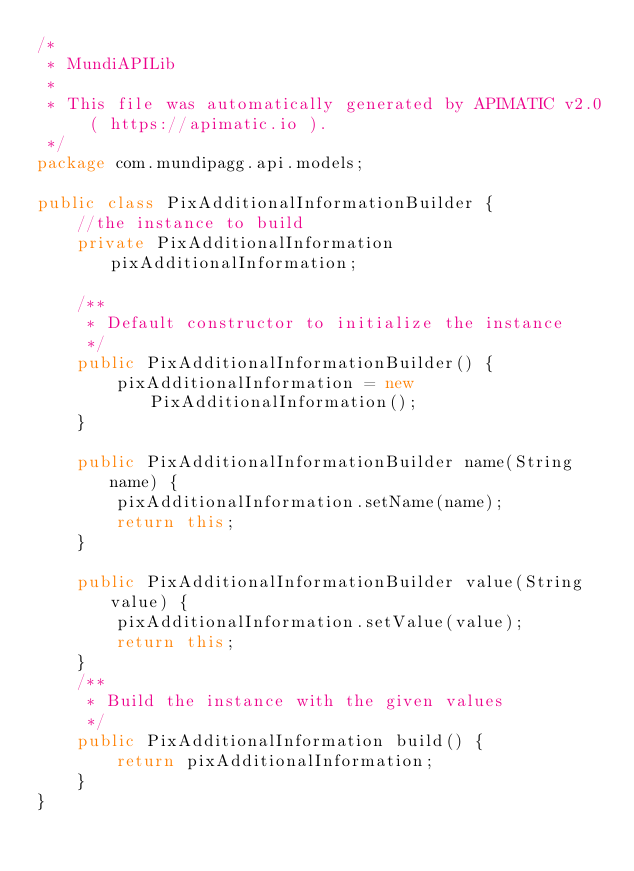Convert code to text. <code><loc_0><loc_0><loc_500><loc_500><_Java_>/*
 * MundiAPILib
 *
 * This file was automatically generated by APIMATIC v2.0 ( https://apimatic.io ).
 */
package com.mundipagg.api.models;

public class PixAdditionalInformationBuilder {
    //the instance to build
    private PixAdditionalInformation pixAdditionalInformation;

    /**
     * Default constructor to initialize the instance
     */
    public PixAdditionalInformationBuilder() {
        pixAdditionalInformation = new PixAdditionalInformation();
    }

    public PixAdditionalInformationBuilder name(String name) {
        pixAdditionalInformation.setName(name);
        return this;
    }

    public PixAdditionalInformationBuilder value(String value) {
        pixAdditionalInformation.setValue(value);
        return this;
    }
    /**
     * Build the instance with the given values
     */
    public PixAdditionalInformation build() {
        return pixAdditionalInformation;
    }
}</code> 